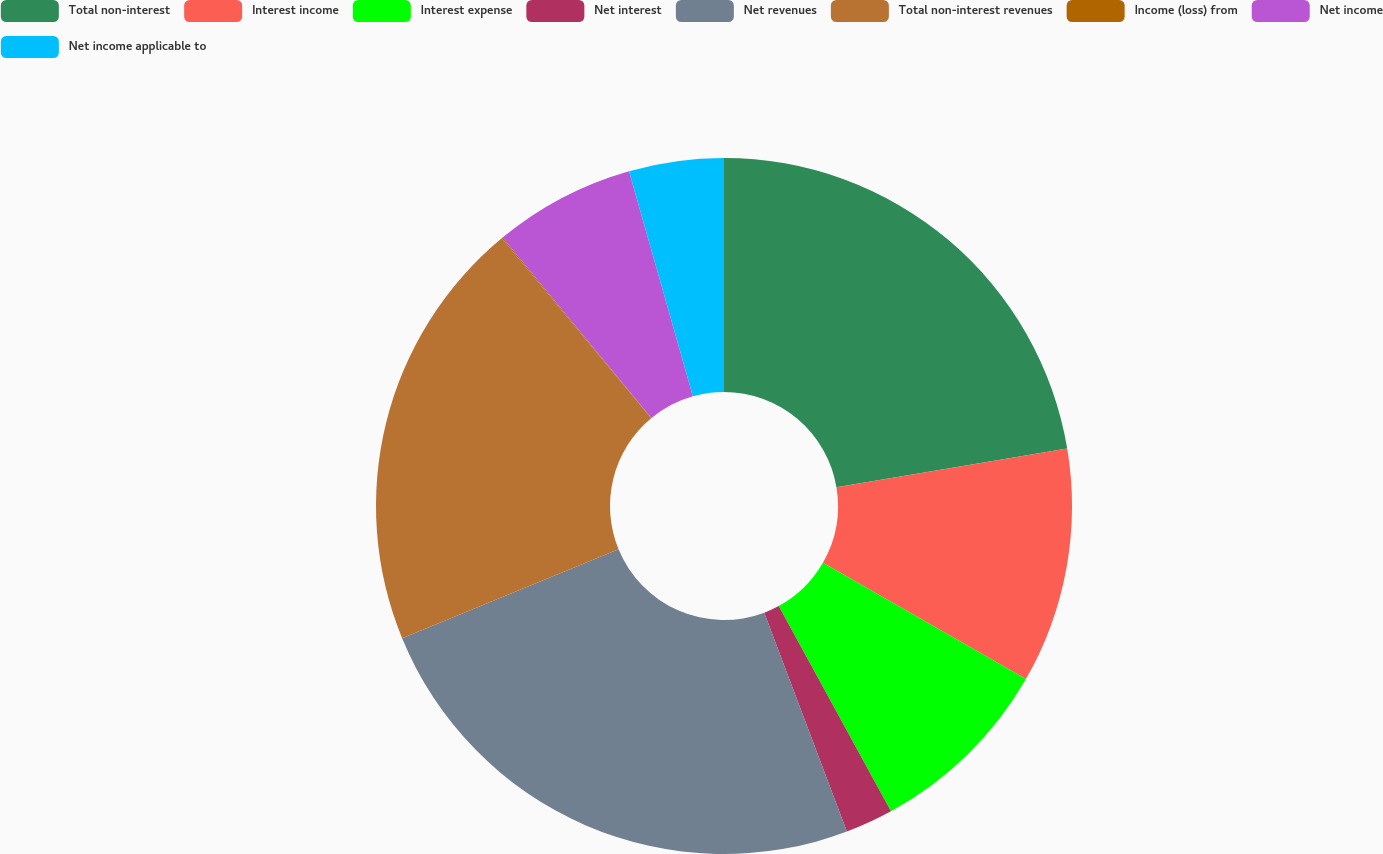Convert chart to OTSL. <chart><loc_0><loc_0><loc_500><loc_500><pie_chart><fcel>Total non-interest<fcel>Interest income<fcel>Interest expense<fcel>Net interest<fcel>Net revenues<fcel>Total non-interest revenues<fcel>Income (loss) from<fcel>Net income<fcel>Net income applicable to<nl><fcel>22.36%<fcel>10.93%<fcel>8.75%<fcel>2.22%<fcel>24.54%<fcel>20.18%<fcel>0.05%<fcel>6.58%<fcel>4.4%<nl></chart> 